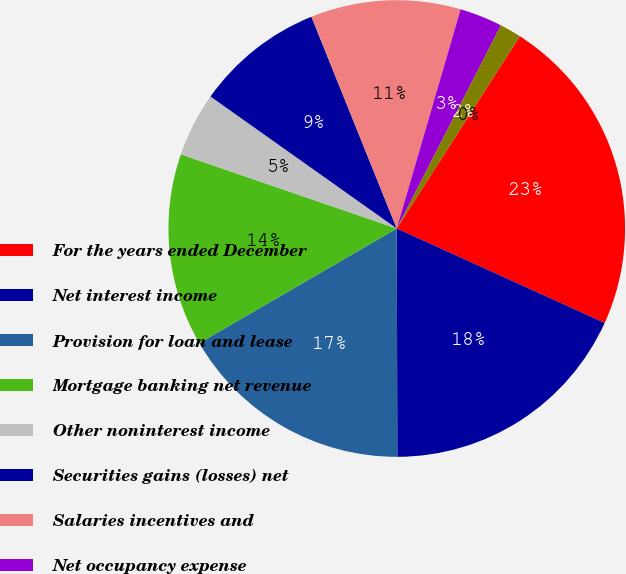<chart> <loc_0><loc_0><loc_500><loc_500><pie_chart><fcel>For the years ended December<fcel>Net interest income<fcel>Provision for loan and lease<fcel>Mortgage banking net revenue<fcel>Other noninterest income<fcel>Securities gains (losses) net<fcel>Salaries incentives and<fcel>Net occupancy expense<fcel>Technology and communications<fcel>Equipment expense<nl><fcel>22.73%<fcel>18.18%<fcel>16.67%<fcel>13.64%<fcel>4.55%<fcel>9.09%<fcel>10.61%<fcel>3.03%<fcel>1.52%<fcel>0.0%<nl></chart> 